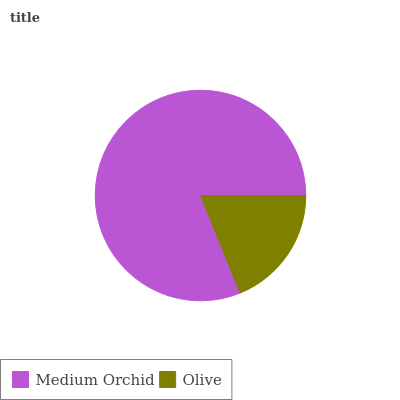Is Olive the minimum?
Answer yes or no. Yes. Is Medium Orchid the maximum?
Answer yes or no. Yes. Is Olive the maximum?
Answer yes or no. No. Is Medium Orchid greater than Olive?
Answer yes or no. Yes. Is Olive less than Medium Orchid?
Answer yes or no. Yes. Is Olive greater than Medium Orchid?
Answer yes or no. No. Is Medium Orchid less than Olive?
Answer yes or no. No. Is Medium Orchid the high median?
Answer yes or no. Yes. Is Olive the low median?
Answer yes or no. Yes. Is Olive the high median?
Answer yes or no. No. Is Medium Orchid the low median?
Answer yes or no. No. 